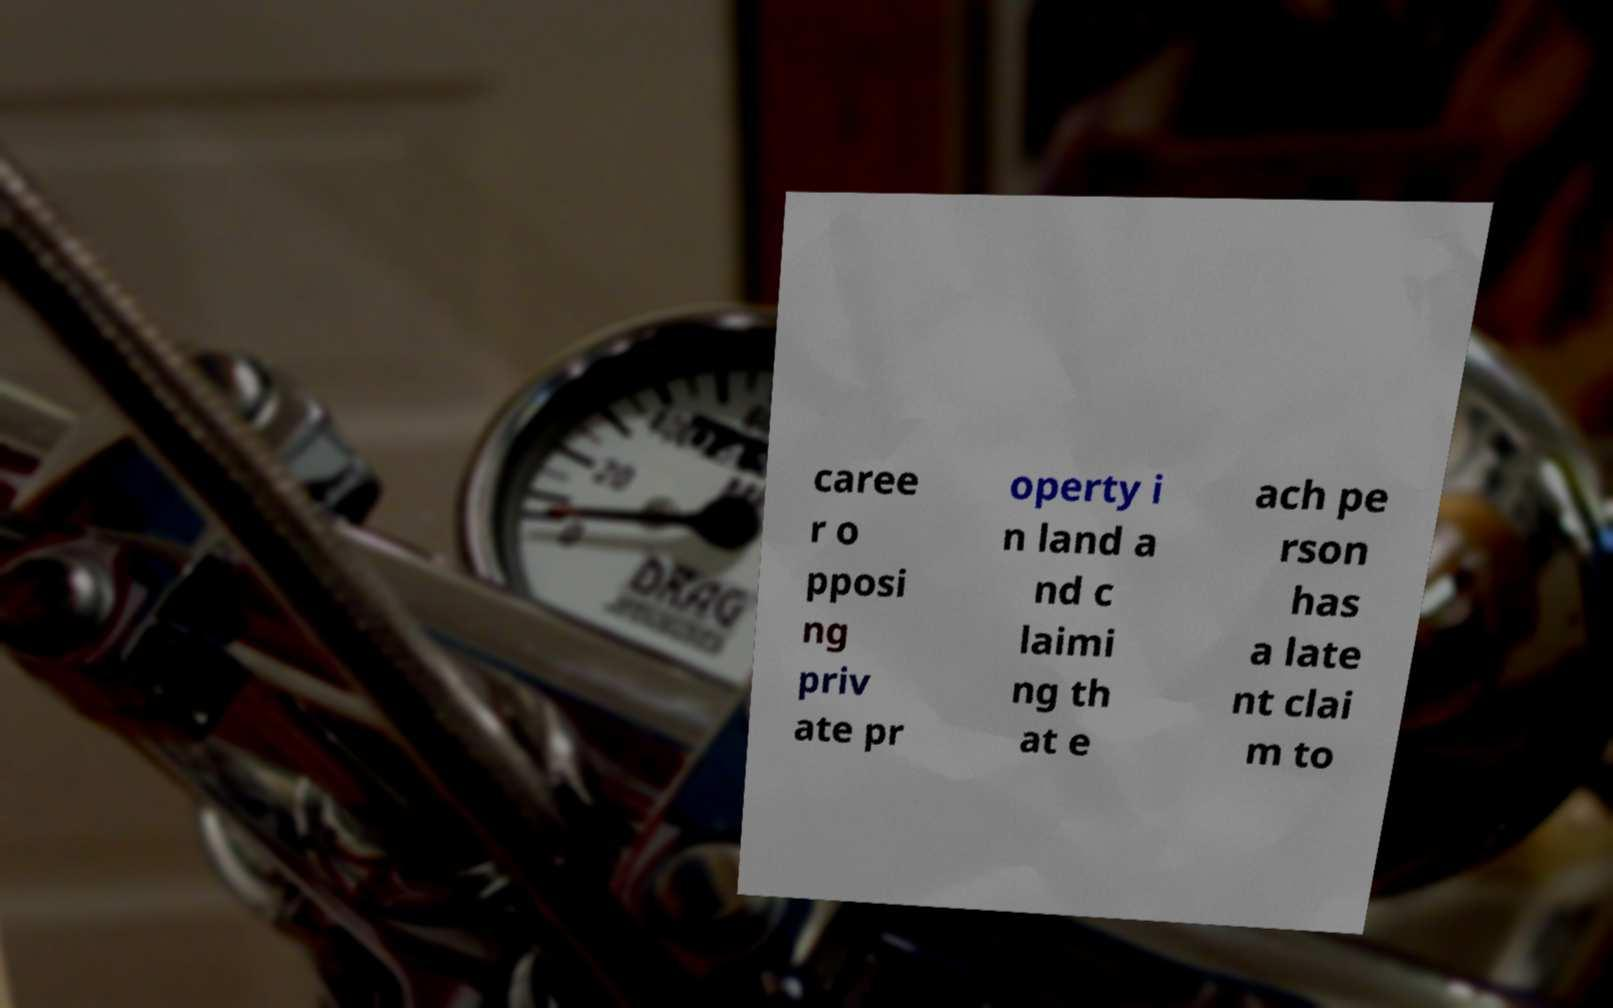Can you read and provide the text displayed in the image?This photo seems to have some interesting text. Can you extract and type it out for me? caree r o pposi ng priv ate pr operty i n land a nd c laimi ng th at e ach pe rson has a late nt clai m to 